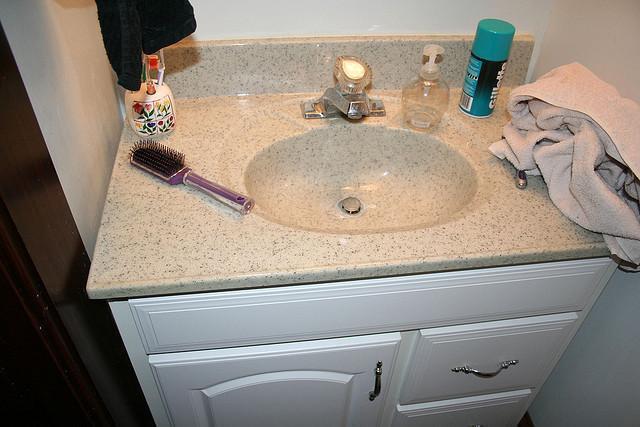How many bottles are there?
Give a very brief answer. 2. 